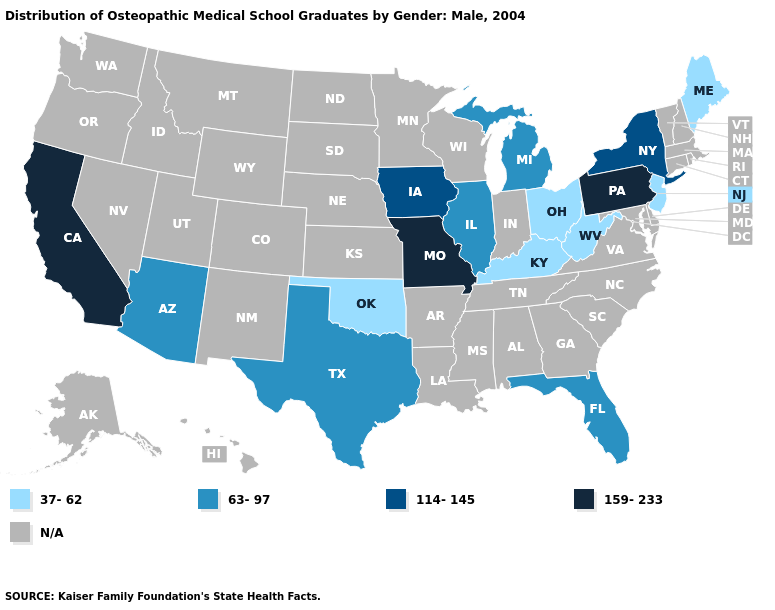Name the states that have a value in the range 159-233?
Short answer required. California, Missouri, Pennsylvania. What is the highest value in the West ?
Answer briefly. 159-233. Which states have the highest value in the USA?
Give a very brief answer. California, Missouri, Pennsylvania. Name the states that have a value in the range 37-62?
Be succinct. Kentucky, Maine, New Jersey, Ohio, Oklahoma, West Virginia. Name the states that have a value in the range 63-97?
Keep it brief. Arizona, Florida, Illinois, Michigan, Texas. Name the states that have a value in the range 159-233?
Keep it brief. California, Missouri, Pennsylvania. Which states have the highest value in the USA?
Answer briefly. California, Missouri, Pennsylvania. Which states have the lowest value in the USA?
Give a very brief answer. Kentucky, Maine, New Jersey, Ohio, Oklahoma, West Virginia. How many symbols are there in the legend?
Be succinct. 5. Among the states that border Indiana , does Kentucky have the lowest value?
Give a very brief answer. Yes. Which states hav the highest value in the MidWest?
Give a very brief answer. Missouri. 